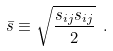Convert formula to latex. <formula><loc_0><loc_0><loc_500><loc_500>\bar { s } \equiv \sqrt { \frac { s _ { i j } s _ { i j } } { 2 } } \ .</formula> 